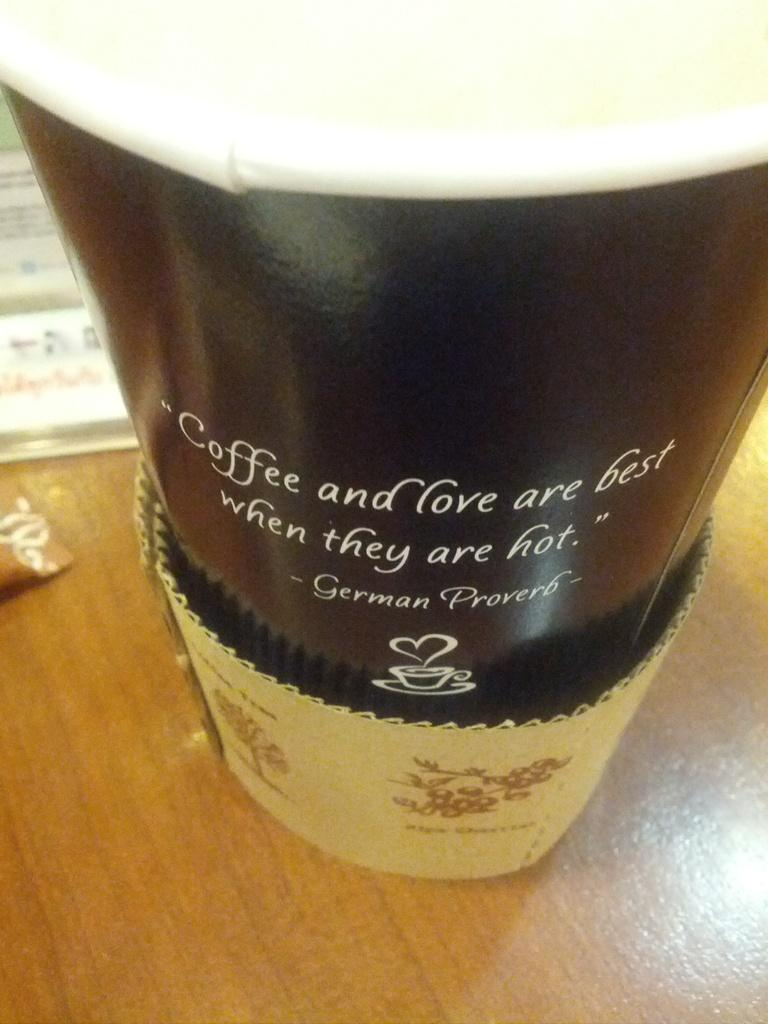Provide a one-sentence caption for the provided image. A coffee cup with a quote from a German Proverb on it. 